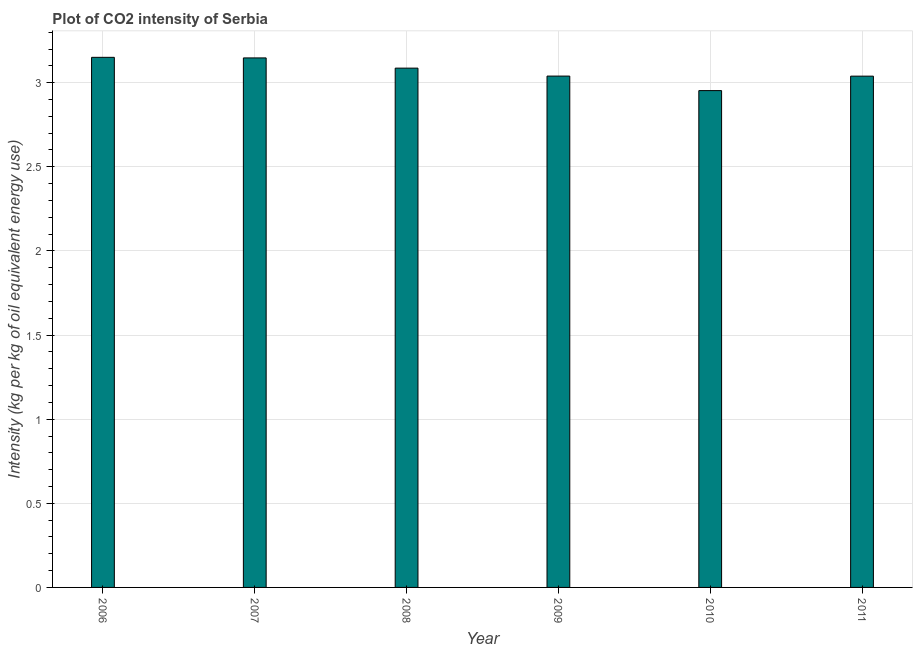Does the graph contain grids?
Offer a very short reply. Yes. What is the title of the graph?
Provide a short and direct response. Plot of CO2 intensity of Serbia. What is the label or title of the Y-axis?
Your answer should be very brief. Intensity (kg per kg of oil equivalent energy use). What is the co2 intensity in 2009?
Make the answer very short. 3.04. Across all years, what is the maximum co2 intensity?
Your response must be concise. 3.15. Across all years, what is the minimum co2 intensity?
Your answer should be compact. 2.95. In which year was the co2 intensity minimum?
Your answer should be compact. 2010. What is the sum of the co2 intensity?
Your answer should be very brief. 18.42. What is the difference between the co2 intensity in 2008 and 2010?
Make the answer very short. 0.13. What is the average co2 intensity per year?
Give a very brief answer. 3.07. What is the median co2 intensity?
Give a very brief answer. 3.06. In how many years, is the co2 intensity greater than 2.1 kg?
Keep it short and to the point. 6. What is the ratio of the co2 intensity in 2008 to that in 2009?
Your answer should be very brief. 1.02. Is the difference between the co2 intensity in 2008 and 2010 greater than the difference between any two years?
Ensure brevity in your answer.  No. What is the difference between the highest and the second highest co2 intensity?
Your answer should be very brief. 0. Is the sum of the co2 intensity in 2006 and 2007 greater than the maximum co2 intensity across all years?
Offer a very short reply. Yes. In how many years, is the co2 intensity greater than the average co2 intensity taken over all years?
Keep it short and to the point. 3. How many years are there in the graph?
Give a very brief answer. 6. What is the difference between two consecutive major ticks on the Y-axis?
Provide a short and direct response. 0.5. What is the Intensity (kg per kg of oil equivalent energy use) of 2006?
Keep it short and to the point. 3.15. What is the Intensity (kg per kg of oil equivalent energy use) in 2007?
Provide a short and direct response. 3.15. What is the Intensity (kg per kg of oil equivalent energy use) of 2008?
Offer a very short reply. 3.09. What is the Intensity (kg per kg of oil equivalent energy use) in 2009?
Provide a succinct answer. 3.04. What is the Intensity (kg per kg of oil equivalent energy use) of 2010?
Keep it short and to the point. 2.95. What is the Intensity (kg per kg of oil equivalent energy use) in 2011?
Provide a succinct answer. 3.04. What is the difference between the Intensity (kg per kg of oil equivalent energy use) in 2006 and 2007?
Keep it short and to the point. 0. What is the difference between the Intensity (kg per kg of oil equivalent energy use) in 2006 and 2008?
Ensure brevity in your answer.  0.06. What is the difference between the Intensity (kg per kg of oil equivalent energy use) in 2006 and 2009?
Your response must be concise. 0.11. What is the difference between the Intensity (kg per kg of oil equivalent energy use) in 2006 and 2010?
Provide a short and direct response. 0.2. What is the difference between the Intensity (kg per kg of oil equivalent energy use) in 2006 and 2011?
Provide a succinct answer. 0.11. What is the difference between the Intensity (kg per kg of oil equivalent energy use) in 2007 and 2008?
Offer a very short reply. 0.06. What is the difference between the Intensity (kg per kg of oil equivalent energy use) in 2007 and 2009?
Offer a very short reply. 0.11. What is the difference between the Intensity (kg per kg of oil equivalent energy use) in 2007 and 2010?
Offer a very short reply. 0.19. What is the difference between the Intensity (kg per kg of oil equivalent energy use) in 2007 and 2011?
Give a very brief answer. 0.11. What is the difference between the Intensity (kg per kg of oil equivalent energy use) in 2008 and 2009?
Your response must be concise. 0.05. What is the difference between the Intensity (kg per kg of oil equivalent energy use) in 2008 and 2010?
Give a very brief answer. 0.13. What is the difference between the Intensity (kg per kg of oil equivalent energy use) in 2008 and 2011?
Offer a very short reply. 0.05. What is the difference between the Intensity (kg per kg of oil equivalent energy use) in 2009 and 2010?
Ensure brevity in your answer.  0.09. What is the difference between the Intensity (kg per kg of oil equivalent energy use) in 2010 and 2011?
Offer a terse response. -0.09. What is the ratio of the Intensity (kg per kg of oil equivalent energy use) in 2006 to that in 2007?
Your response must be concise. 1. What is the ratio of the Intensity (kg per kg of oil equivalent energy use) in 2006 to that in 2010?
Provide a short and direct response. 1.07. What is the ratio of the Intensity (kg per kg of oil equivalent energy use) in 2007 to that in 2009?
Give a very brief answer. 1.04. What is the ratio of the Intensity (kg per kg of oil equivalent energy use) in 2007 to that in 2010?
Provide a short and direct response. 1.07. What is the ratio of the Intensity (kg per kg of oil equivalent energy use) in 2007 to that in 2011?
Provide a short and direct response. 1.04. What is the ratio of the Intensity (kg per kg of oil equivalent energy use) in 2008 to that in 2010?
Provide a succinct answer. 1.04. What is the ratio of the Intensity (kg per kg of oil equivalent energy use) in 2008 to that in 2011?
Offer a terse response. 1.02. What is the ratio of the Intensity (kg per kg of oil equivalent energy use) in 2009 to that in 2010?
Give a very brief answer. 1.03. What is the ratio of the Intensity (kg per kg of oil equivalent energy use) in 2010 to that in 2011?
Ensure brevity in your answer.  0.97. 